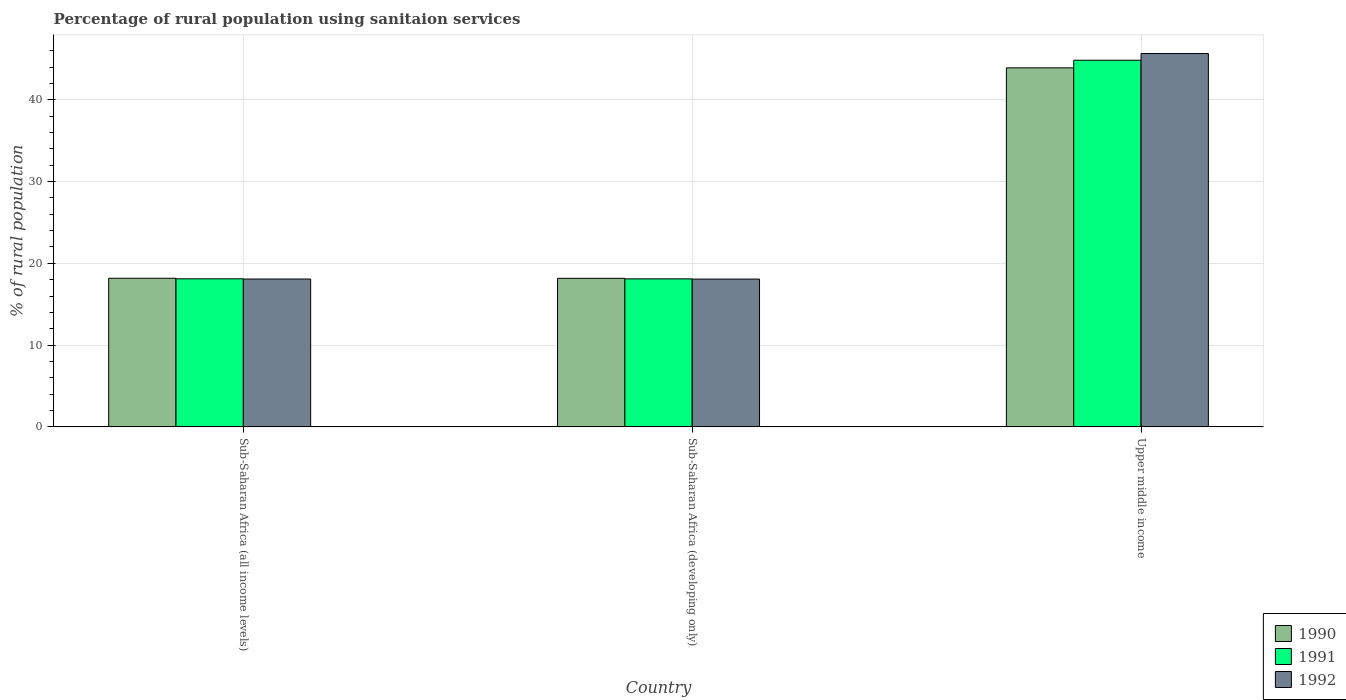How many different coloured bars are there?
Offer a very short reply. 3. How many groups of bars are there?
Offer a terse response. 3. Are the number of bars per tick equal to the number of legend labels?
Provide a short and direct response. Yes. How many bars are there on the 1st tick from the left?
Provide a short and direct response. 3. How many bars are there on the 1st tick from the right?
Your answer should be very brief. 3. What is the label of the 3rd group of bars from the left?
Your answer should be very brief. Upper middle income. In how many cases, is the number of bars for a given country not equal to the number of legend labels?
Keep it short and to the point. 0. What is the percentage of rural population using sanitaion services in 1991 in Sub-Saharan Africa (developing only)?
Ensure brevity in your answer.  18.1. Across all countries, what is the maximum percentage of rural population using sanitaion services in 1992?
Your answer should be compact. 45.65. Across all countries, what is the minimum percentage of rural population using sanitaion services in 1990?
Make the answer very short. 18.16. In which country was the percentage of rural population using sanitaion services in 1990 maximum?
Your answer should be very brief. Upper middle income. In which country was the percentage of rural population using sanitaion services in 1991 minimum?
Offer a very short reply. Sub-Saharan Africa (developing only). What is the total percentage of rural population using sanitaion services in 1991 in the graph?
Offer a very short reply. 81.03. What is the difference between the percentage of rural population using sanitaion services in 1991 in Sub-Saharan Africa (developing only) and that in Upper middle income?
Your response must be concise. -26.73. What is the difference between the percentage of rural population using sanitaion services in 1991 in Upper middle income and the percentage of rural population using sanitaion services in 1990 in Sub-Saharan Africa (all income levels)?
Your answer should be compact. 26.66. What is the average percentage of rural population using sanitaion services in 1991 per country?
Provide a short and direct response. 27.01. What is the difference between the percentage of rural population using sanitaion services of/in 1991 and percentage of rural population using sanitaion services of/in 1990 in Upper middle income?
Provide a short and direct response. 0.93. In how many countries, is the percentage of rural population using sanitaion services in 1991 greater than 32 %?
Offer a terse response. 1. What is the ratio of the percentage of rural population using sanitaion services in 1990 in Sub-Saharan Africa (all income levels) to that in Upper middle income?
Provide a short and direct response. 0.41. Is the percentage of rural population using sanitaion services in 1991 in Sub-Saharan Africa (all income levels) less than that in Upper middle income?
Your answer should be very brief. Yes. Is the difference between the percentage of rural population using sanitaion services in 1991 in Sub-Saharan Africa (developing only) and Upper middle income greater than the difference between the percentage of rural population using sanitaion services in 1990 in Sub-Saharan Africa (developing only) and Upper middle income?
Offer a very short reply. No. What is the difference between the highest and the second highest percentage of rural population using sanitaion services in 1991?
Ensure brevity in your answer.  0.01. What is the difference between the highest and the lowest percentage of rural population using sanitaion services in 1990?
Your response must be concise. 25.74. In how many countries, is the percentage of rural population using sanitaion services in 1992 greater than the average percentage of rural population using sanitaion services in 1992 taken over all countries?
Your answer should be very brief. 1. Is the sum of the percentage of rural population using sanitaion services in 1990 in Sub-Saharan Africa (all income levels) and Sub-Saharan Africa (developing only) greater than the maximum percentage of rural population using sanitaion services in 1991 across all countries?
Ensure brevity in your answer.  No. What does the 1st bar from the left in Upper middle income represents?
Give a very brief answer. 1990. What does the 3rd bar from the right in Sub-Saharan Africa (all income levels) represents?
Your answer should be compact. 1990. How many bars are there?
Keep it short and to the point. 9. Are all the bars in the graph horizontal?
Provide a succinct answer. No. How many countries are there in the graph?
Ensure brevity in your answer.  3. Are the values on the major ticks of Y-axis written in scientific E-notation?
Your answer should be very brief. No. Does the graph contain grids?
Offer a terse response. Yes. How are the legend labels stacked?
Provide a succinct answer. Vertical. What is the title of the graph?
Your response must be concise. Percentage of rural population using sanitaion services. What is the label or title of the X-axis?
Offer a very short reply. Country. What is the label or title of the Y-axis?
Offer a very short reply. % of rural population. What is the % of rural population of 1990 in Sub-Saharan Africa (all income levels)?
Ensure brevity in your answer.  18.17. What is the % of rural population in 1991 in Sub-Saharan Africa (all income levels)?
Your answer should be compact. 18.1. What is the % of rural population of 1992 in Sub-Saharan Africa (all income levels)?
Provide a short and direct response. 18.08. What is the % of rural population in 1990 in Sub-Saharan Africa (developing only)?
Keep it short and to the point. 18.16. What is the % of rural population of 1991 in Sub-Saharan Africa (developing only)?
Your response must be concise. 18.1. What is the % of rural population of 1992 in Sub-Saharan Africa (developing only)?
Provide a succinct answer. 18.07. What is the % of rural population of 1990 in Upper middle income?
Provide a short and direct response. 43.9. What is the % of rural population of 1991 in Upper middle income?
Offer a very short reply. 44.83. What is the % of rural population of 1992 in Upper middle income?
Offer a terse response. 45.65. Across all countries, what is the maximum % of rural population of 1990?
Offer a very short reply. 43.9. Across all countries, what is the maximum % of rural population in 1991?
Give a very brief answer. 44.83. Across all countries, what is the maximum % of rural population of 1992?
Keep it short and to the point. 45.65. Across all countries, what is the minimum % of rural population in 1990?
Ensure brevity in your answer.  18.16. Across all countries, what is the minimum % of rural population in 1991?
Make the answer very short. 18.1. Across all countries, what is the minimum % of rural population of 1992?
Your answer should be compact. 18.07. What is the total % of rural population in 1990 in the graph?
Offer a very short reply. 80.23. What is the total % of rural population in 1991 in the graph?
Your response must be concise. 81.03. What is the total % of rural population in 1992 in the graph?
Make the answer very short. 81.79. What is the difference between the % of rural population in 1990 in Sub-Saharan Africa (all income levels) and that in Sub-Saharan Africa (developing only)?
Ensure brevity in your answer.  0.01. What is the difference between the % of rural population in 1991 in Sub-Saharan Africa (all income levels) and that in Sub-Saharan Africa (developing only)?
Ensure brevity in your answer.  0.01. What is the difference between the % of rural population in 1992 in Sub-Saharan Africa (all income levels) and that in Sub-Saharan Africa (developing only)?
Keep it short and to the point. 0.01. What is the difference between the % of rural population in 1990 in Sub-Saharan Africa (all income levels) and that in Upper middle income?
Keep it short and to the point. -25.73. What is the difference between the % of rural population in 1991 in Sub-Saharan Africa (all income levels) and that in Upper middle income?
Ensure brevity in your answer.  -26.72. What is the difference between the % of rural population in 1992 in Sub-Saharan Africa (all income levels) and that in Upper middle income?
Your response must be concise. -27.57. What is the difference between the % of rural population in 1990 in Sub-Saharan Africa (developing only) and that in Upper middle income?
Offer a very short reply. -25.74. What is the difference between the % of rural population of 1991 in Sub-Saharan Africa (developing only) and that in Upper middle income?
Your response must be concise. -26.73. What is the difference between the % of rural population in 1992 in Sub-Saharan Africa (developing only) and that in Upper middle income?
Give a very brief answer. -27.58. What is the difference between the % of rural population in 1990 in Sub-Saharan Africa (all income levels) and the % of rural population in 1991 in Sub-Saharan Africa (developing only)?
Give a very brief answer. 0.07. What is the difference between the % of rural population in 1990 in Sub-Saharan Africa (all income levels) and the % of rural population in 1992 in Sub-Saharan Africa (developing only)?
Make the answer very short. 0.1. What is the difference between the % of rural population in 1991 in Sub-Saharan Africa (all income levels) and the % of rural population in 1992 in Sub-Saharan Africa (developing only)?
Your answer should be very brief. 0.04. What is the difference between the % of rural population of 1990 in Sub-Saharan Africa (all income levels) and the % of rural population of 1991 in Upper middle income?
Offer a very short reply. -26.66. What is the difference between the % of rural population of 1990 in Sub-Saharan Africa (all income levels) and the % of rural population of 1992 in Upper middle income?
Keep it short and to the point. -27.48. What is the difference between the % of rural population in 1991 in Sub-Saharan Africa (all income levels) and the % of rural population in 1992 in Upper middle income?
Keep it short and to the point. -27.54. What is the difference between the % of rural population of 1990 in Sub-Saharan Africa (developing only) and the % of rural population of 1991 in Upper middle income?
Ensure brevity in your answer.  -26.67. What is the difference between the % of rural population in 1990 in Sub-Saharan Africa (developing only) and the % of rural population in 1992 in Upper middle income?
Ensure brevity in your answer.  -27.49. What is the difference between the % of rural population in 1991 in Sub-Saharan Africa (developing only) and the % of rural population in 1992 in Upper middle income?
Provide a short and direct response. -27.55. What is the average % of rural population of 1990 per country?
Make the answer very short. 26.74. What is the average % of rural population of 1991 per country?
Your answer should be very brief. 27.01. What is the average % of rural population in 1992 per country?
Give a very brief answer. 27.26. What is the difference between the % of rural population in 1990 and % of rural population in 1991 in Sub-Saharan Africa (all income levels)?
Ensure brevity in your answer.  0.06. What is the difference between the % of rural population of 1990 and % of rural population of 1992 in Sub-Saharan Africa (all income levels)?
Your answer should be very brief. 0.09. What is the difference between the % of rural population in 1991 and % of rural population in 1992 in Sub-Saharan Africa (all income levels)?
Provide a short and direct response. 0.03. What is the difference between the % of rural population of 1990 and % of rural population of 1991 in Sub-Saharan Africa (developing only)?
Your answer should be very brief. 0.06. What is the difference between the % of rural population in 1990 and % of rural population in 1992 in Sub-Saharan Africa (developing only)?
Your answer should be compact. 0.09. What is the difference between the % of rural population of 1991 and % of rural population of 1992 in Sub-Saharan Africa (developing only)?
Give a very brief answer. 0.03. What is the difference between the % of rural population in 1990 and % of rural population in 1991 in Upper middle income?
Ensure brevity in your answer.  -0.93. What is the difference between the % of rural population in 1990 and % of rural population in 1992 in Upper middle income?
Ensure brevity in your answer.  -1.75. What is the difference between the % of rural population of 1991 and % of rural population of 1992 in Upper middle income?
Provide a short and direct response. -0.82. What is the ratio of the % of rural population in 1990 in Sub-Saharan Africa (all income levels) to that in Upper middle income?
Your response must be concise. 0.41. What is the ratio of the % of rural population in 1991 in Sub-Saharan Africa (all income levels) to that in Upper middle income?
Give a very brief answer. 0.4. What is the ratio of the % of rural population in 1992 in Sub-Saharan Africa (all income levels) to that in Upper middle income?
Offer a terse response. 0.4. What is the ratio of the % of rural population in 1990 in Sub-Saharan Africa (developing only) to that in Upper middle income?
Keep it short and to the point. 0.41. What is the ratio of the % of rural population of 1991 in Sub-Saharan Africa (developing only) to that in Upper middle income?
Give a very brief answer. 0.4. What is the ratio of the % of rural population of 1992 in Sub-Saharan Africa (developing only) to that in Upper middle income?
Offer a very short reply. 0.4. What is the difference between the highest and the second highest % of rural population in 1990?
Offer a very short reply. 25.73. What is the difference between the highest and the second highest % of rural population in 1991?
Provide a short and direct response. 26.72. What is the difference between the highest and the second highest % of rural population in 1992?
Make the answer very short. 27.57. What is the difference between the highest and the lowest % of rural population in 1990?
Your answer should be very brief. 25.74. What is the difference between the highest and the lowest % of rural population of 1991?
Your response must be concise. 26.73. What is the difference between the highest and the lowest % of rural population in 1992?
Give a very brief answer. 27.58. 